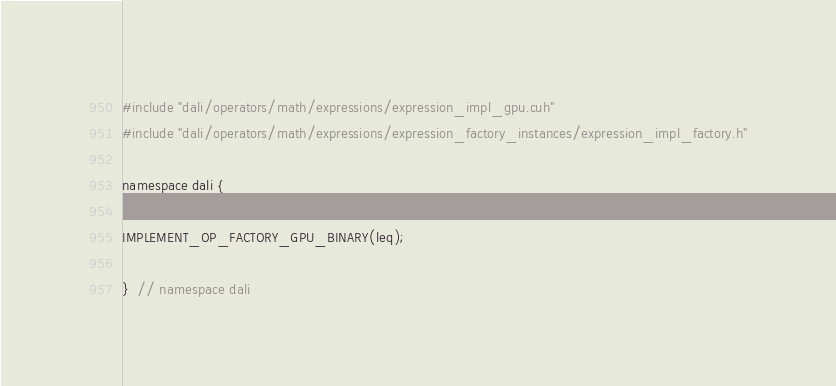<code> <loc_0><loc_0><loc_500><loc_500><_Cuda_>#include "dali/operators/math/expressions/expression_impl_gpu.cuh"
#include "dali/operators/math/expressions/expression_factory_instances/expression_impl_factory.h"

namespace dali {

IMPLEMENT_OP_FACTORY_GPU_BINARY(leq);

}  // namespace dali
</code> 